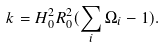<formula> <loc_0><loc_0><loc_500><loc_500>k = H _ { 0 } ^ { 2 } R _ { 0 } ^ { 2 } ( \sum _ { i } \Omega _ { i } - 1 ) .</formula> 